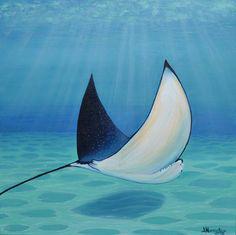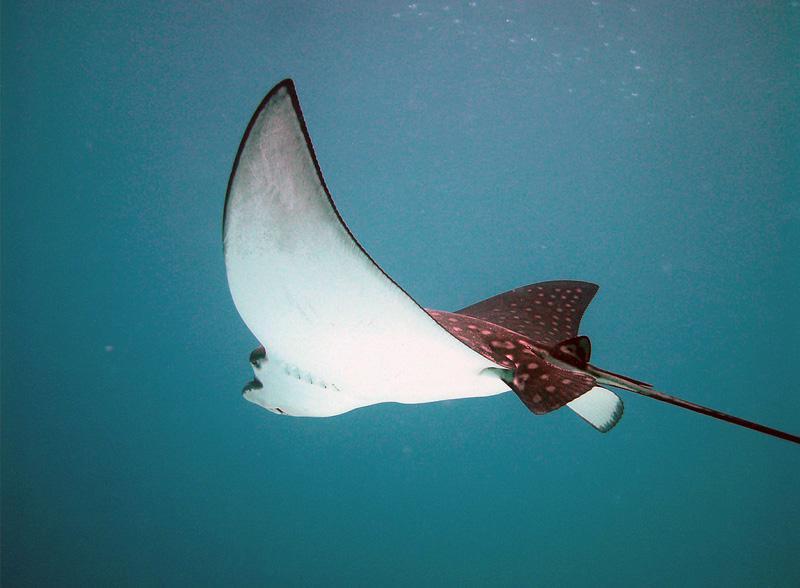The first image is the image on the left, the second image is the image on the right. Assess this claim about the two images: "The sting ray in the right picture is facing towards the left.". Correct or not? Answer yes or no. Yes. The first image is the image on the left, the second image is the image on the right. Examine the images to the left and right. Is the description "All of the stingrays are near the ocean floor." accurate? Answer yes or no. No. 